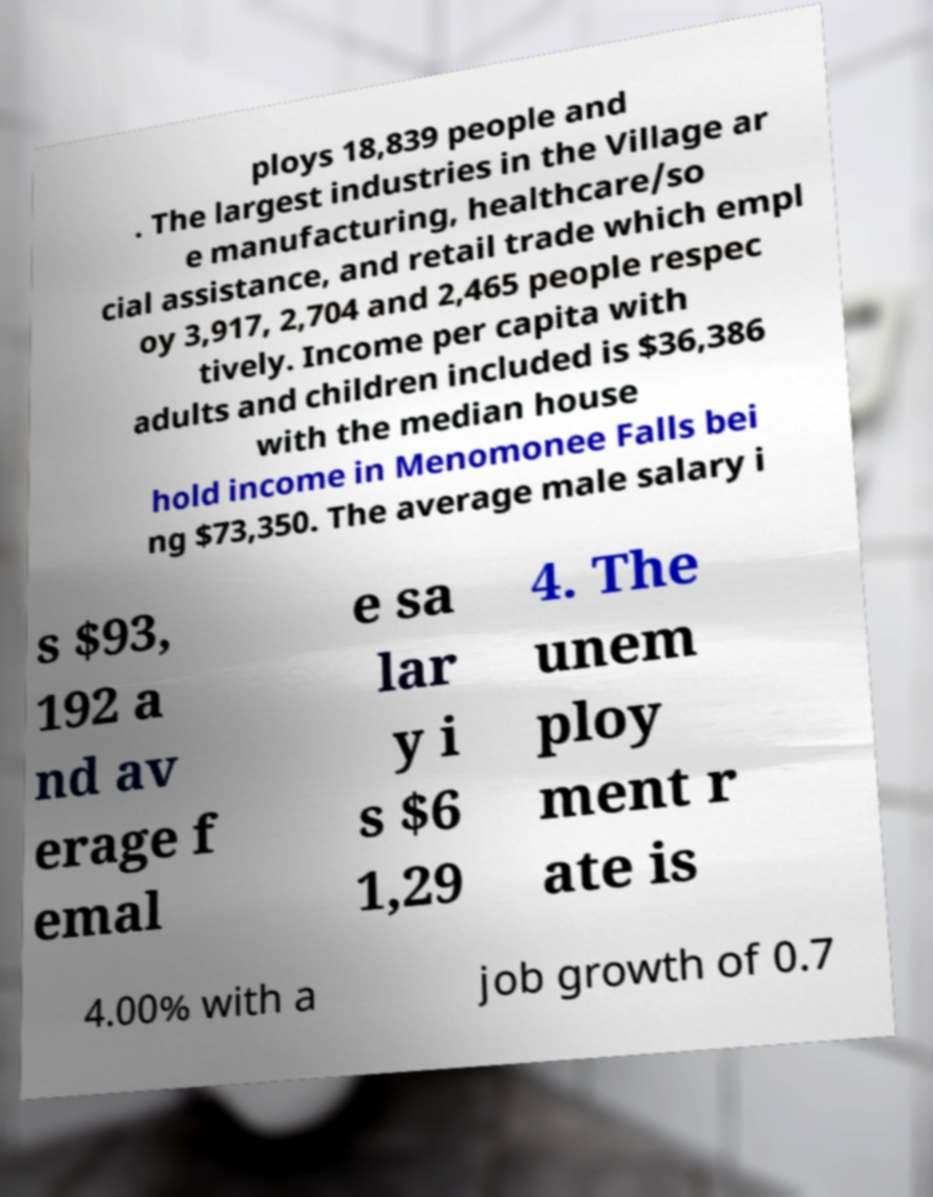Could you assist in decoding the text presented in this image and type it out clearly? ploys 18,839 people and . The largest industries in the Village ar e manufacturing, healthcare/so cial assistance, and retail trade which empl oy 3,917, 2,704 and 2,465 people respec tively. Income per capita with adults and children included is $36,386 with the median house hold income in Menomonee Falls bei ng $73,350. The average male salary i s $93, 192 a nd av erage f emal e sa lar y i s $6 1,29 4. The unem ploy ment r ate is 4.00% with a job growth of 0.7 